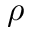<formula> <loc_0><loc_0><loc_500><loc_500>\rho</formula> 